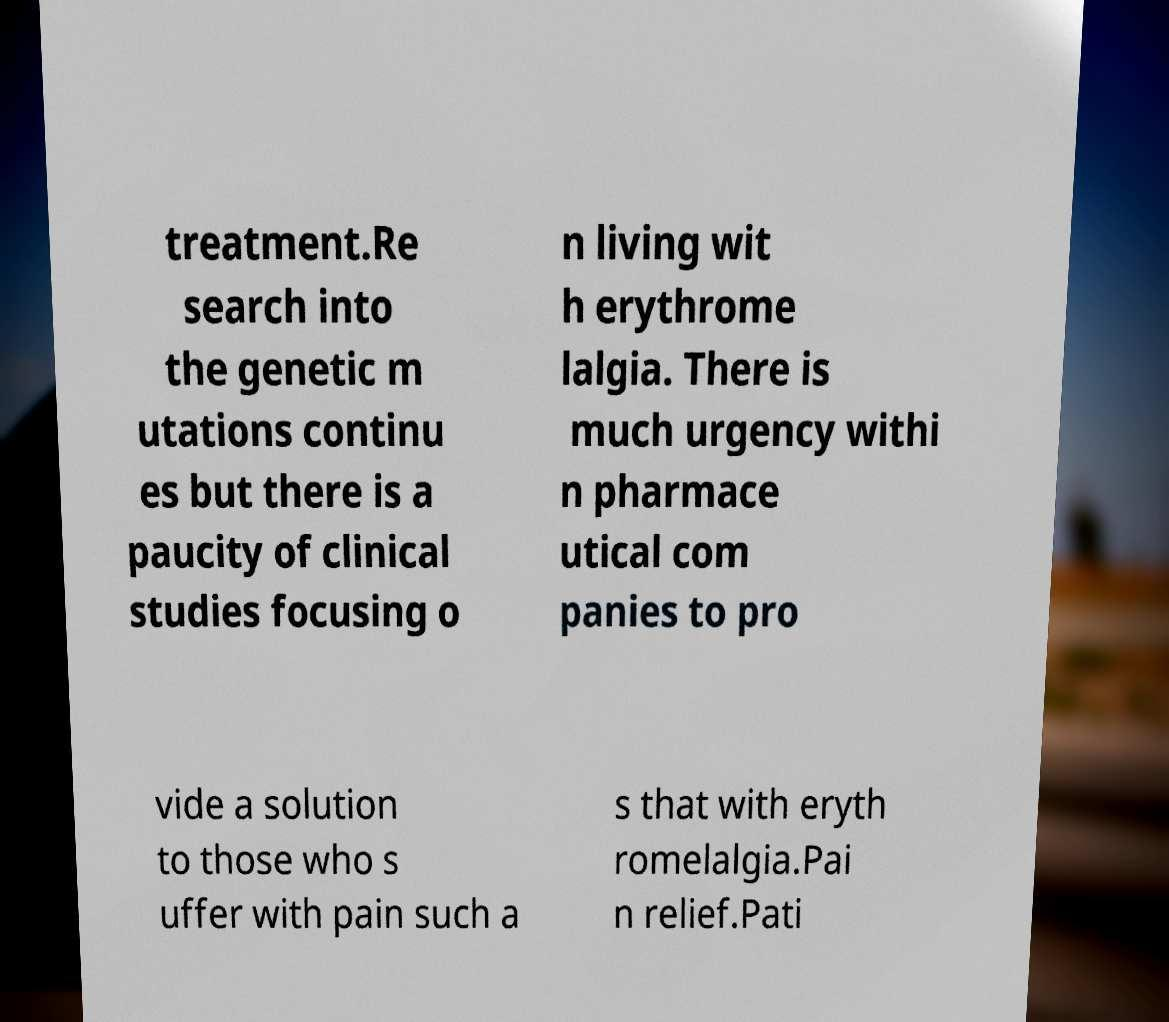Could you assist in decoding the text presented in this image and type it out clearly? treatment.Re search into the genetic m utations continu es but there is a paucity of clinical studies focusing o n living wit h erythrome lalgia. There is much urgency withi n pharmace utical com panies to pro vide a solution to those who s uffer with pain such a s that with eryth romelalgia.Pai n relief.Pati 